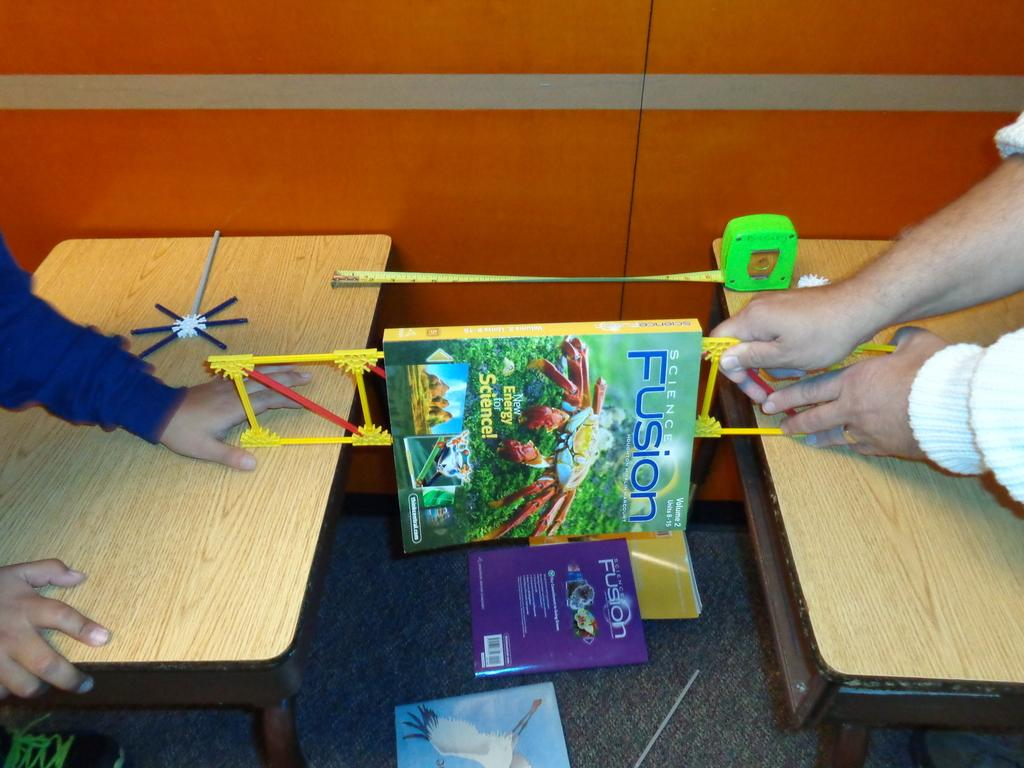How many people are present in the image? There are two people in the image. What are the two people doing in the image? The two people are balancing a book. Are there any other books visible in the image? Yes, there are books on the floor in the image. What type of locket can be seen around the neck of one of the people in the image? There is no locket visible around the neck of either person in the image. What type of glass is being used to balance the book in the image? There is no glass present in the image; the two people are balancing a book without any additional objects. 